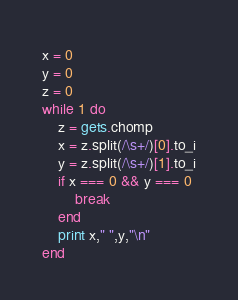Convert code to text. <code><loc_0><loc_0><loc_500><loc_500><_Ruby_>x = 0
y = 0
z = 0
while 1 do
	z = gets.chomp
	x = z.split(/\s+/)[0].to_i
	y = z.split(/\s+/)[1].to_i
	if x === 0 && y === 0
		break
	end
	print x," ",y,"\n"
end</code> 